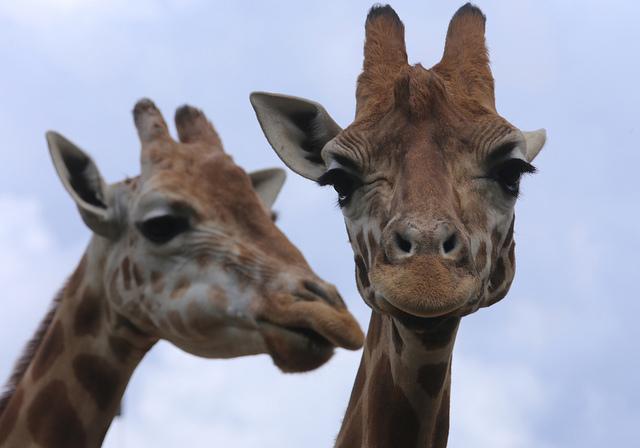Are these animals eating?
Write a very short answer. No. How many ears do these animals have?
Answer briefly. 2. Are the giraffes touching?
Answer briefly. No. 